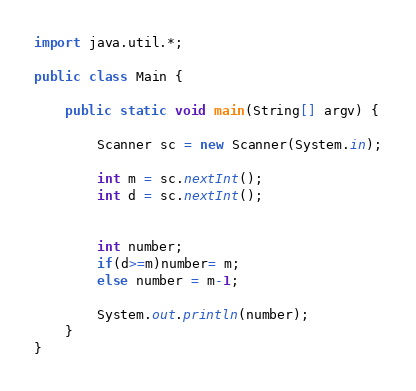Convert code to text. <code><loc_0><loc_0><loc_500><loc_500><_Java_>import java.util.*;

public class Main {

	public static void main(String[] argv) {

		Scanner sc = new Scanner(System.in);
		
		int m = sc.nextInt();
		int d = sc.nextInt();
	
		
		int number;
		if(d>=m)number= m;
		else number = m-1;
		
		System.out.println(number);
	}
}
</code> 